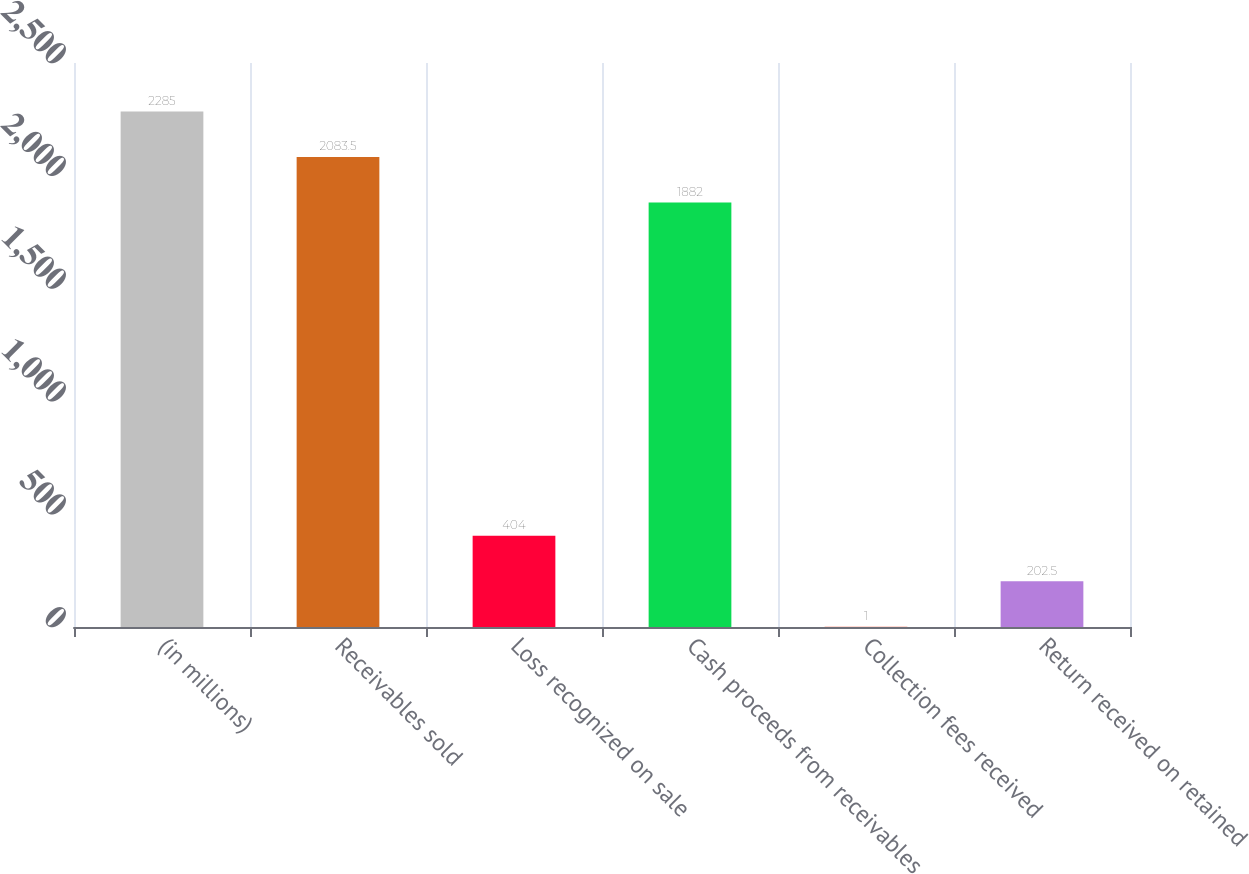Convert chart. <chart><loc_0><loc_0><loc_500><loc_500><bar_chart><fcel>(in millions)<fcel>Receivables sold<fcel>Loss recognized on sale<fcel>Cash proceeds from receivables<fcel>Collection fees received<fcel>Return received on retained<nl><fcel>2285<fcel>2083.5<fcel>404<fcel>1882<fcel>1<fcel>202.5<nl></chart> 